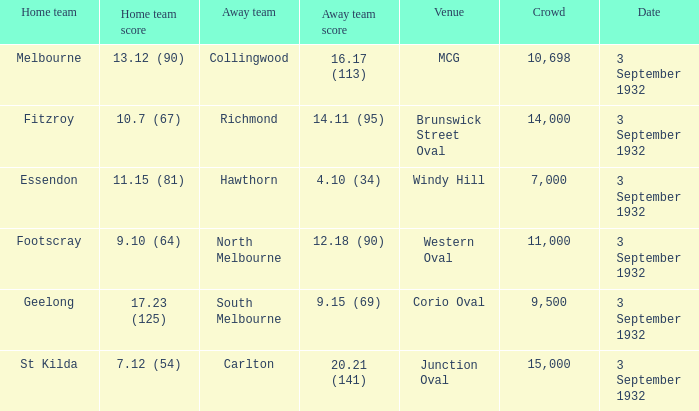Can you provide the name of the stadium where the away team achieved a score of 14.11 (95)? Brunswick Street Oval. 